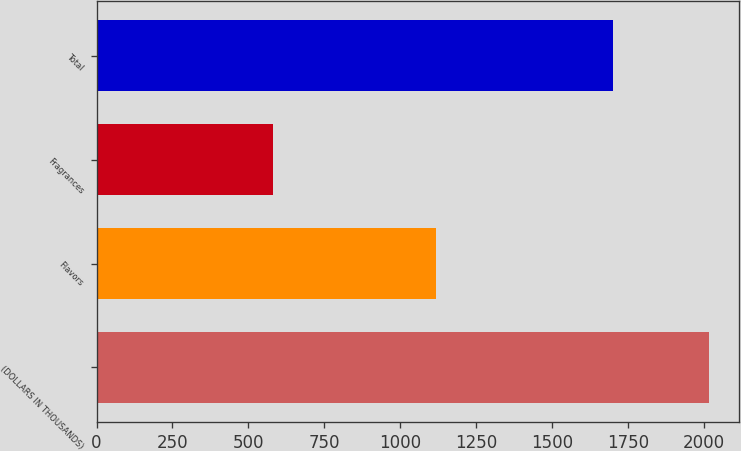<chart> <loc_0><loc_0><loc_500><loc_500><bar_chart><fcel>(DOLLARS IN THOUSANDS)<fcel>Flavors<fcel>Fragrances<fcel>Total<nl><fcel>2016<fcel>1119<fcel>581<fcel>1700<nl></chart> 